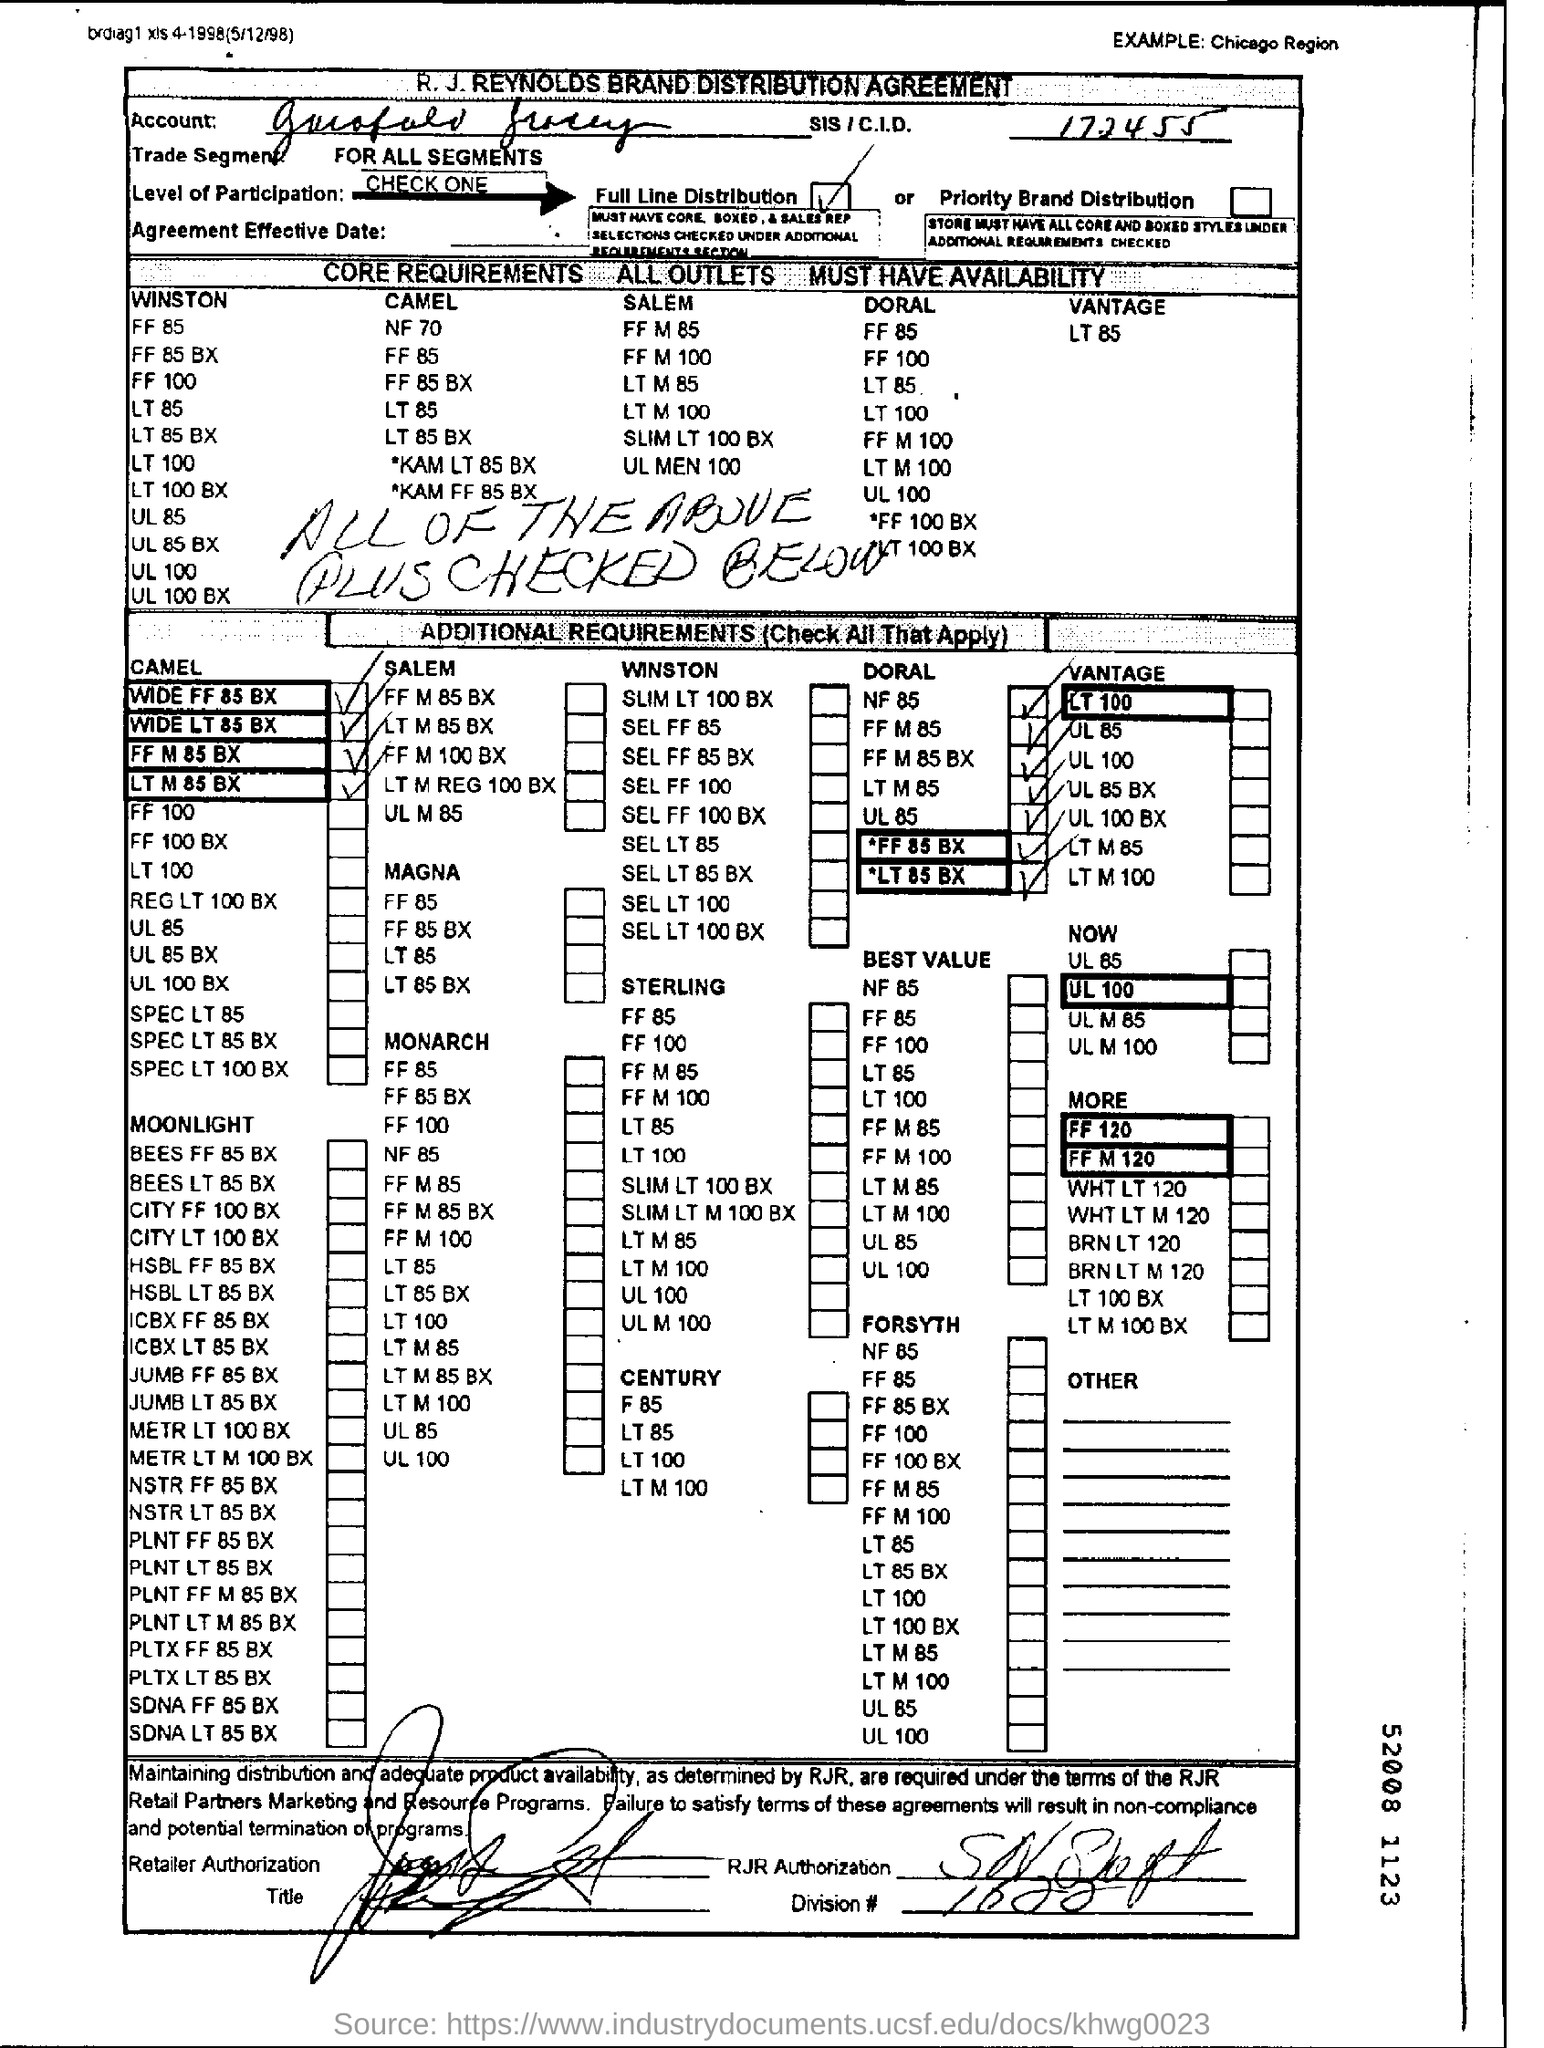Point out several critical features in this image. The name of the company at the top of the document is R. J. REYNOLDS BRAND DISTRIBUTION AGREEMENT. The text written on the top right corner of the example provided is 'Chicago Region.' 